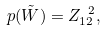Convert formula to latex. <formula><loc_0><loc_0><loc_500><loc_500>p ( \tilde { W } ) = Z _ { 1 2 } ^ { \ 2 } ,</formula> 